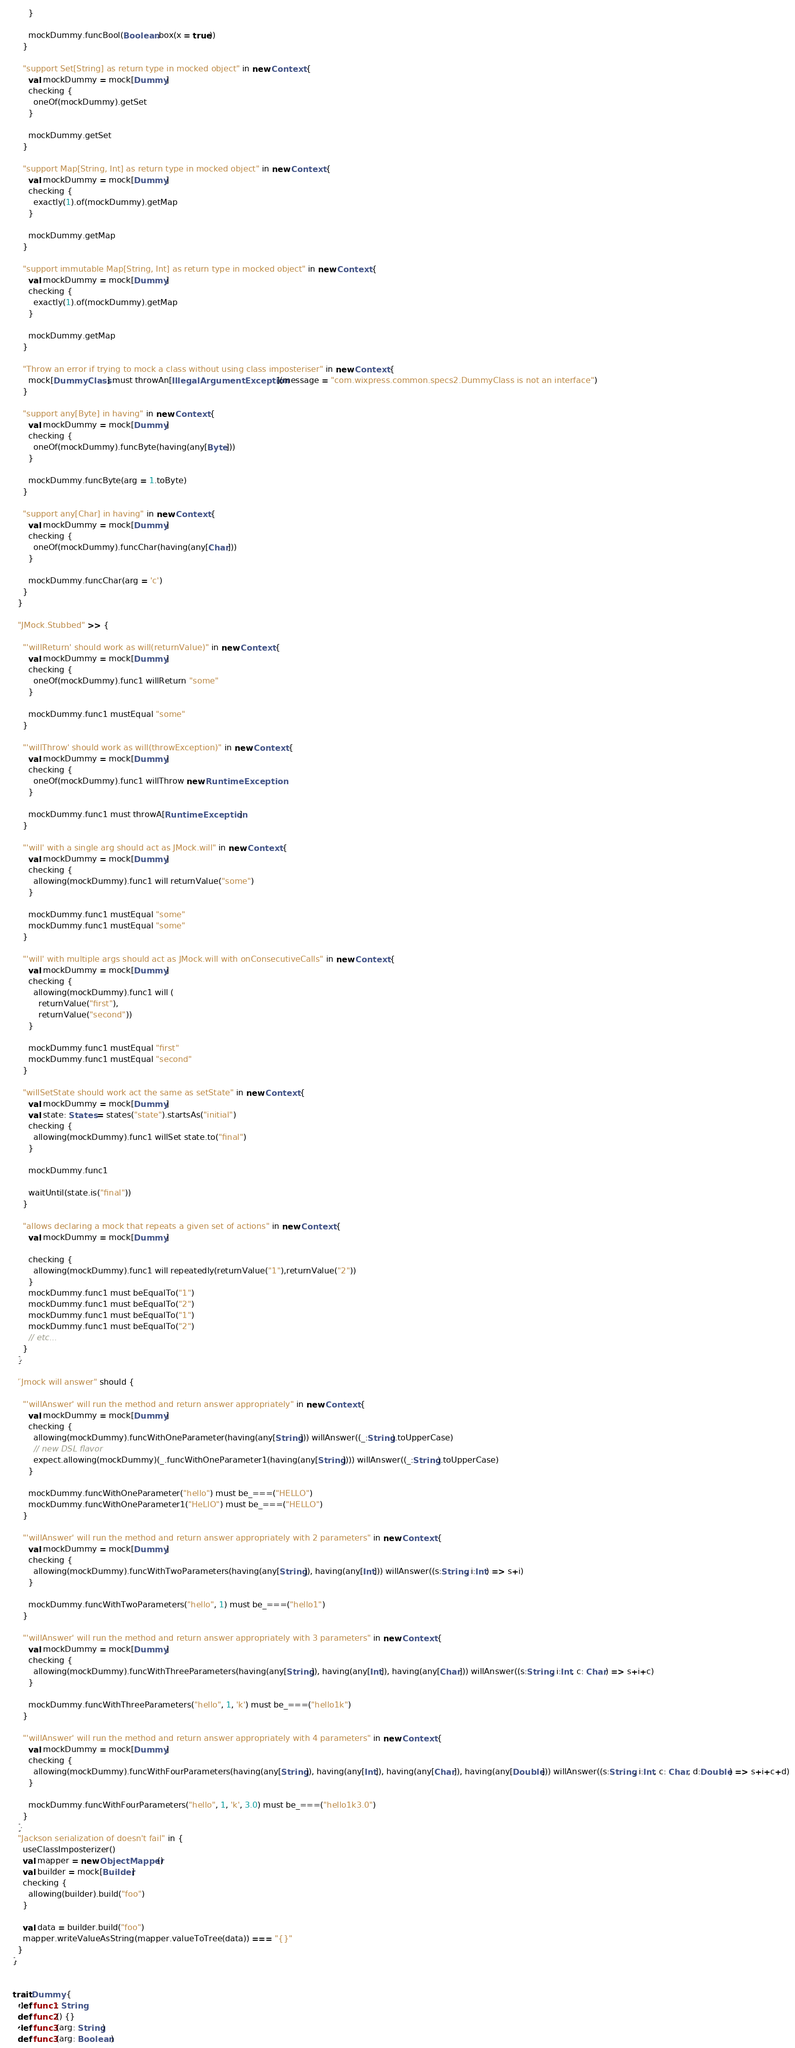Convert code to text. <code><loc_0><loc_0><loc_500><loc_500><_Scala_>      }

      mockDummy.funcBool(Boolean.box(x = true))
    }

    "support Set[String] as return type in mocked object" in new Context {
      val mockDummy = mock[Dummy]
      checking {
        oneOf(mockDummy).getSet
      }

      mockDummy.getSet
    }

    "support Map[String, Int] as return type in mocked object" in new Context {
      val mockDummy = mock[Dummy]
      checking {
        exactly(1).of(mockDummy).getMap
      }

      mockDummy.getMap
    }

    "support immutable Map[String, Int] as return type in mocked object" in new Context {
      val mockDummy = mock[Dummy]
      checking {
        exactly(1).of(mockDummy).getMap
      }

      mockDummy.getMap
    }

    "Throw an error if trying to mock a class without using class imposteriser" in new Context {
      mock[DummyClass] must throwAn[IllegalArgumentException](message = "com.wixpress.common.specs2.DummyClass is not an interface")
    }

    "support any[Byte] in having" in new Context {
      val mockDummy = mock[Dummy]
      checking {
        oneOf(mockDummy).funcByte(having(any[Byte]))
      }

      mockDummy.funcByte(arg = 1.toByte)
    }

    "support any[Char] in having" in new Context {
      val mockDummy = mock[Dummy]
      checking {
        oneOf(mockDummy).funcChar(having(any[Char]))
      }

      mockDummy.funcChar(arg = 'c')
    }
  }

  "JMock.Stubbed" >> {

    "'willReturn' should work as will(returnValue)" in new Context {
      val mockDummy = mock[Dummy]
      checking {
        oneOf(mockDummy).func1 willReturn "some"
      }

      mockDummy.func1 mustEqual "some"
    }

    "'willThrow' should work as will(throwException)" in new Context {
      val mockDummy = mock[Dummy]
      checking {
        oneOf(mockDummy).func1 willThrow new RuntimeException
      }

      mockDummy.func1 must throwA[RuntimeException]
    }

    "'will' with a single arg should act as JMock.will" in new Context {
      val mockDummy = mock[Dummy]
      checking {
        allowing(mockDummy).func1 will returnValue("some")
      }

      mockDummy.func1 mustEqual "some"
      mockDummy.func1 mustEqual "some"
    }

    "'will' with multiple args should act as JMock.will with onConsecutiveCalls" in new Context {
      val mockDummy = mock[Dummy]
      checking {
        allowing(mockDummy).func1 will (
          returnValue("first"),
          returnValue("second"))
      }

      mockDummy.func1 mustEqual "first"
      mockDummy.func1 mustEqual "second"
    }

    "willSetState should work act the same as setState" in new Context {
      val mockDummy = mock[Dummy]
      val state: States = states("state").startsAs("initial")
      checking {
        allowing(mockDummy).func1 willSet state.to("final")
      }

      mockDummy.func1

      waitUntil(state.is("final"))
    }

    "allows declaring a mock that repeats a given set of actions" in new Context {
      val mockDummy = mock[Dummy]

      checking {
        allowing(mockDummy).func1 will repeatedly(returnValue("1"),returnValue("2"))
      }
      mockDummy.func1 must beEqualTo("1")
      mockDummy.func1 must beEqualTo("2")
      mockDummy.func1 must beEqualTo("1")
      mockDummy.func1 must beEqualTo("2")
      // etc...
    }
  }

  "Jmock will answer" should {

    "'willAnswer' will run the method and return answer appropriately" in new Context {
      val mockDummy = mock[Dummy]
      checking {
        allowing(mockDummy).funcWithOneParameter(having(any[String])) willAnswer((_:String).toUpperCase)
        // new DSL flavor
        expect.allowing(mockDummy)(_.funcWithOneParameter1(having(any[String]))) willAnswer((_:String).toUpperCase)
      }

      mockDummy.funcWithOneParameter("hello") must be_===("HELLO")
      mockDummy.funcWithOneParameter1("HeLlO") must be_===("HELLO")
    }

    "'willAnswer' will run the method and return answer appropriately with 2 parameters" in new Context {
      val mockDummy = mock[Dummy]
      checking {
        allowing(mockDummy).funcWithTwoParameters(having(any[String]), having(any[Int])) willAnswer((s:String, i:Int) => s+i)
      }

      mockDummy.funcWithTwoParameters("hello", 1) must be_===("hello1")
    }

    "'willAnswer' will run the method and return answer appropriately with 3 parameters" in new Context {
      val mockDummy = mock[Dummy]
      checking {
        allowing(mockDummy).funcWithThreeParameters(having(any[String]), having(any[Int]), having(any[Char])) willAnswer((s:String, i:Int, c: Char) => s+i+c)
      }

      mockDummy.funcWithThreeParameters("hello", 1, 'k') must be_===("hello1k")
    }

    "'willAnswer' will run the method and return answer appropriately with 4 parameters" in new Context {
      val mockDummy = mock[Dummy]
      checking {
        allowing(mockDummy).funcWithFourParameters(having(any[String]), having(any[Int]), having(any[Char]), having(any[Double])) willAnswer((s:String, i:Int, c: Char, d:Double) => s+i+c+d)
      }

      mockDummy.funcWithFourParameters("hello", 1, 'k', 3.0) must be_===("hello1k3.0")
    }
  }
  "Jackson serialization of doesn't fail" in {
    useClassImposterizer()
    val mapper = new ObjectMapper()
    val builder = mock[Builder]
    checking {
      allowing(builder).build("foo")
    }

    val data = builder.build("foo")
    mapper.writeValueAsString(mapper.valueToTree(data)) === "{}"
  }
}


trait Dummy {
  def func1: String
  def func2() {}
  def func3(arg: String)
  def func3(arg: Boolean)</code> 